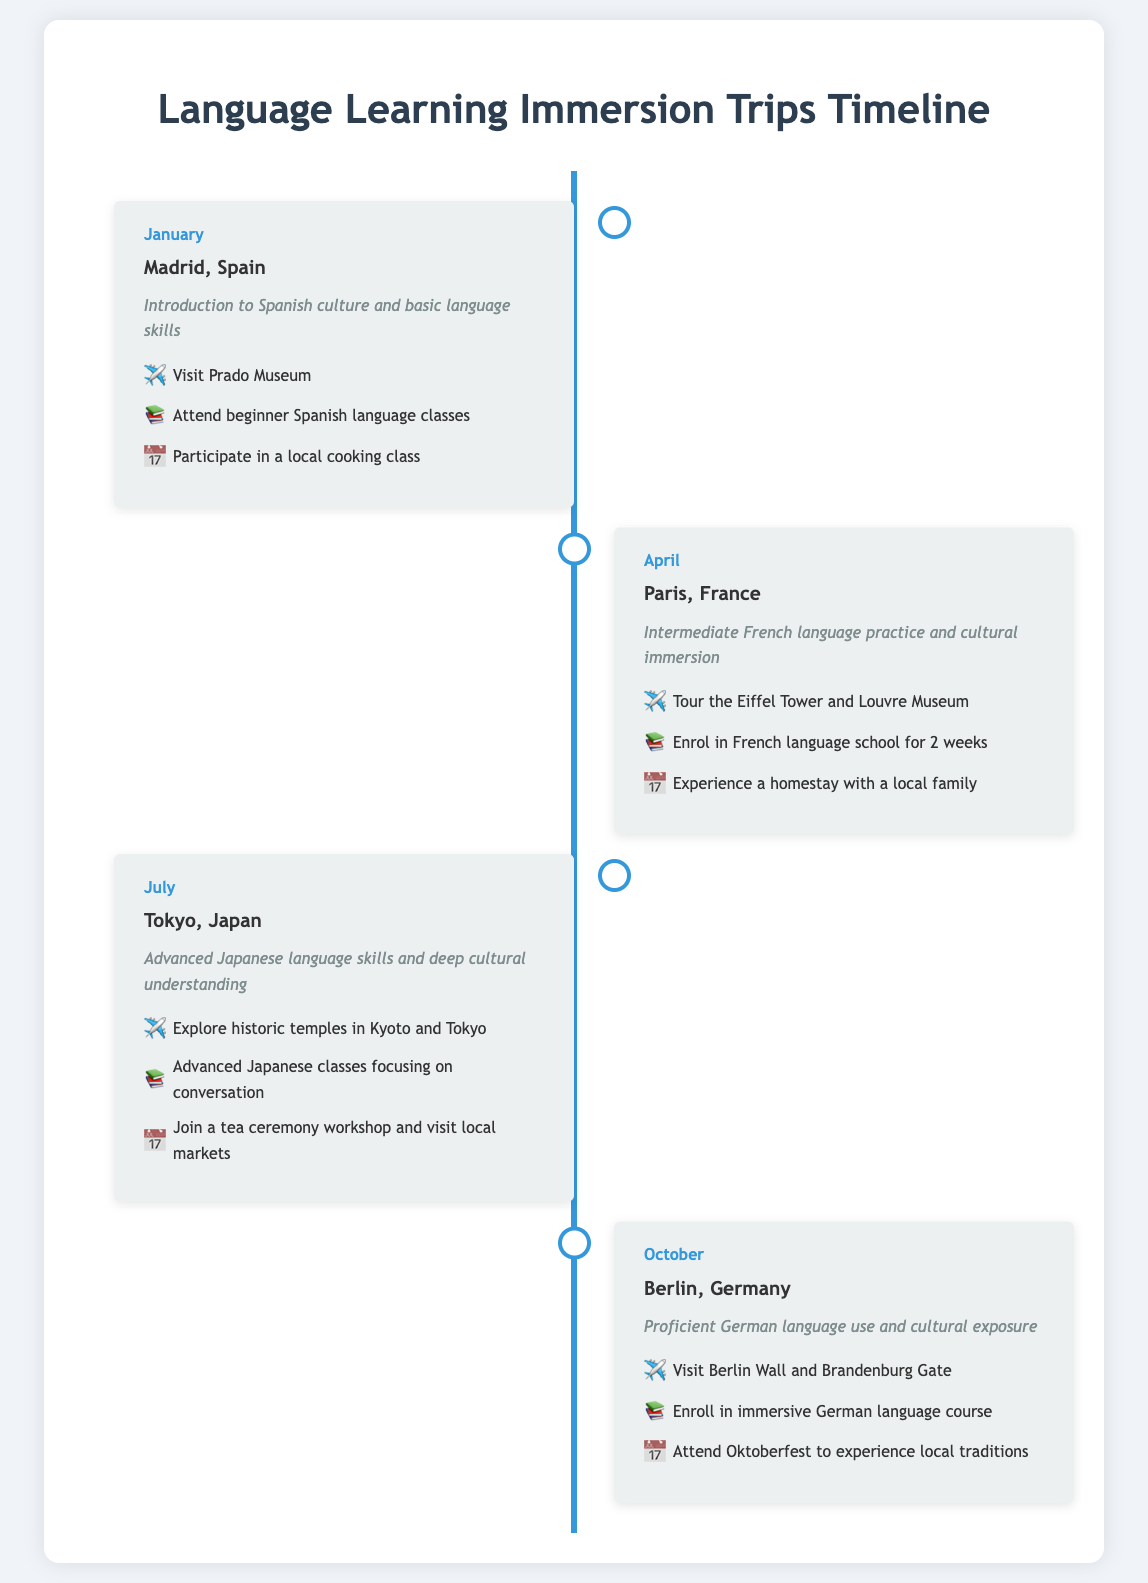What is the first destination mentioned? The first destination in the timeline is listed as Madrid, Spain in January.
Answer: Madrid, Spain How many language classes are offered in Tokyo? The document indicates that advanced Japanese classes focusing on conversation are offered in Tokyo.
Answer: One What month is the Berlin trip scheduled for? The Berlin trip is scheduled for October as per the timeline entries.
Answer: October What cultural event will be attended in Berlin? The document specifies attending Oktoberfest to experience local traditions in Berlin.
Answer: Oktoberfest Which destination features a homestay? A homestay experience is highlighted in the Paris, France entry of the timeline.
Answer: Paris, France What is the goal of the trip to Tokyo? The goal of the trip to Tokyo is to achieve advanced Japanese language skills and deep cultural understanding.
Answer: Advanced Japanese language skills and deep cultural understanding How many months are covered in the timeline? The timeline covers four months, as indicated by the entries listed.
Answer: Four Which city will students visit historic temples in? The document mentions exploring historic temples in Kyoto and Tokyo during the trip.
Answer: Kyoto and Tokyo What types of activities are listed for the trip to Madrid? The activities listed for Madrid include visiting Prado Museum, attending beginner Spanish classes, and participating in a local cooking class.
Answer: Visit Prado Museum, attend beginner Spanish classes, participate in a local cooking class 